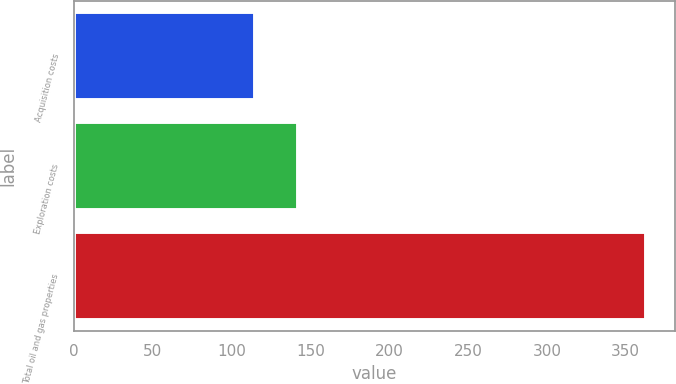Convert chart. <chart><loc_0><loc_0><loc_500><loc_500><bar_chart><fcel>Acquisition costs<fcel>Exploration costs<fcel>Total oil and gas properties<nl><fcel>115<fcel>142<fcel>363<nl></chart> 